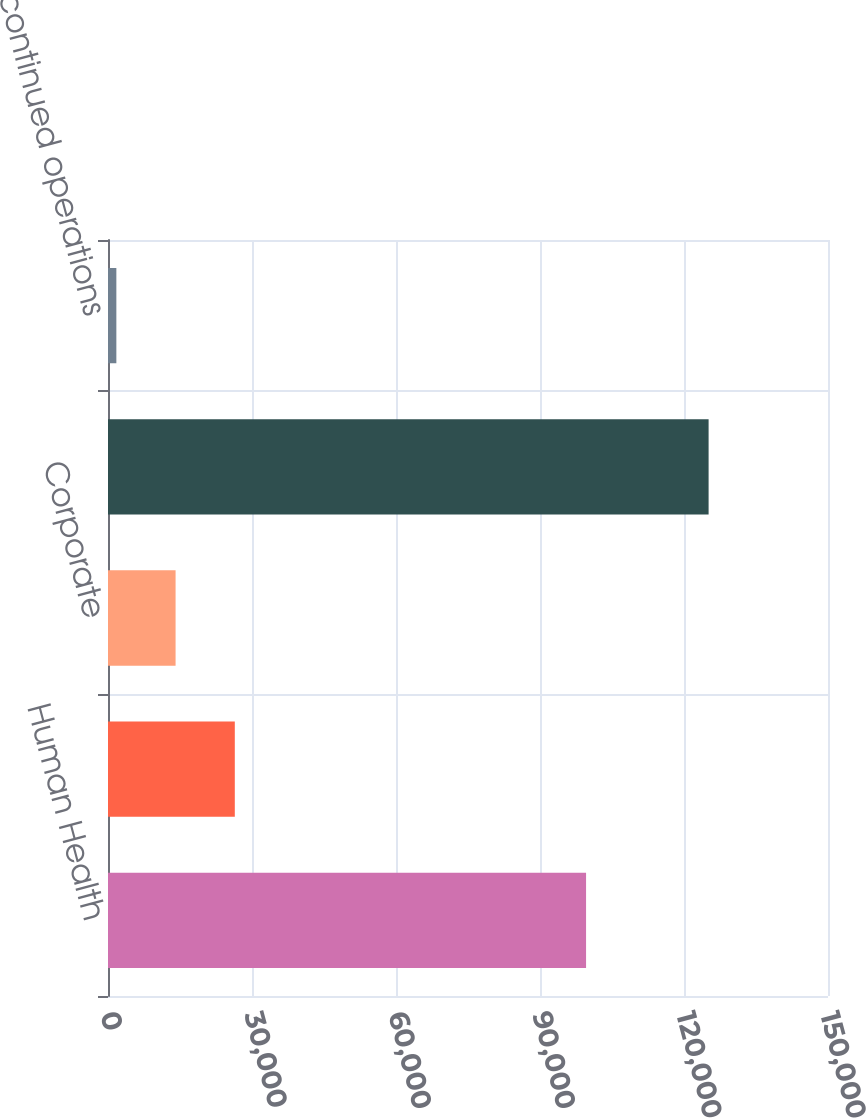Convert chart. <chart><loc_0><loc_0><loc_500><loc_500><bar_chart><fcel>Human Health<fcel>Environmental Health<fcel>Corporate<fcel>Continuing operations<fcel>Discontinued operations<nl><fcel>99597<fcel>26418<fcel>14079.5<fcel>125126<fcel>1741<nl></chart> 